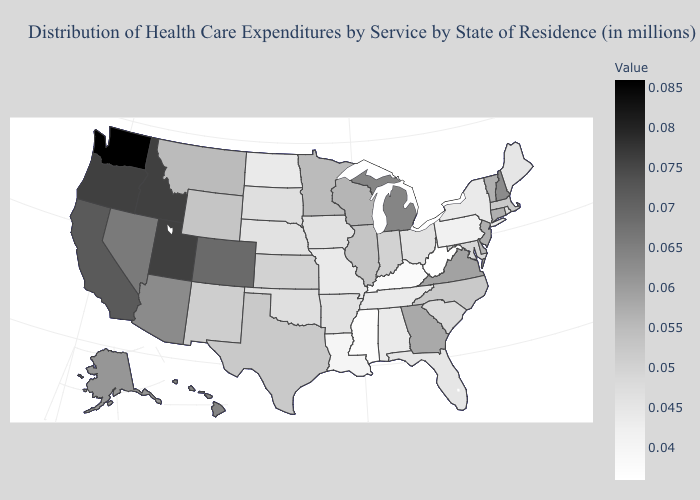Among the states that border Utah , which have the lowest value?
Be succinct. New Mexico. Does Washington have the highest value in the USA?
Concise answer only. Yes. Among the states that border New Hampshire , does Vermont have the highest value?
Answer briefly. Yes. Which states have the lowest value in the Northeast?
Write a very short answer. Pennsylvania. Does West Virginia have the lowest value in the USA?
Be succinct. Yes. Does Massachusetts have a higher value than Oregon?
Write a very short answer. No. 